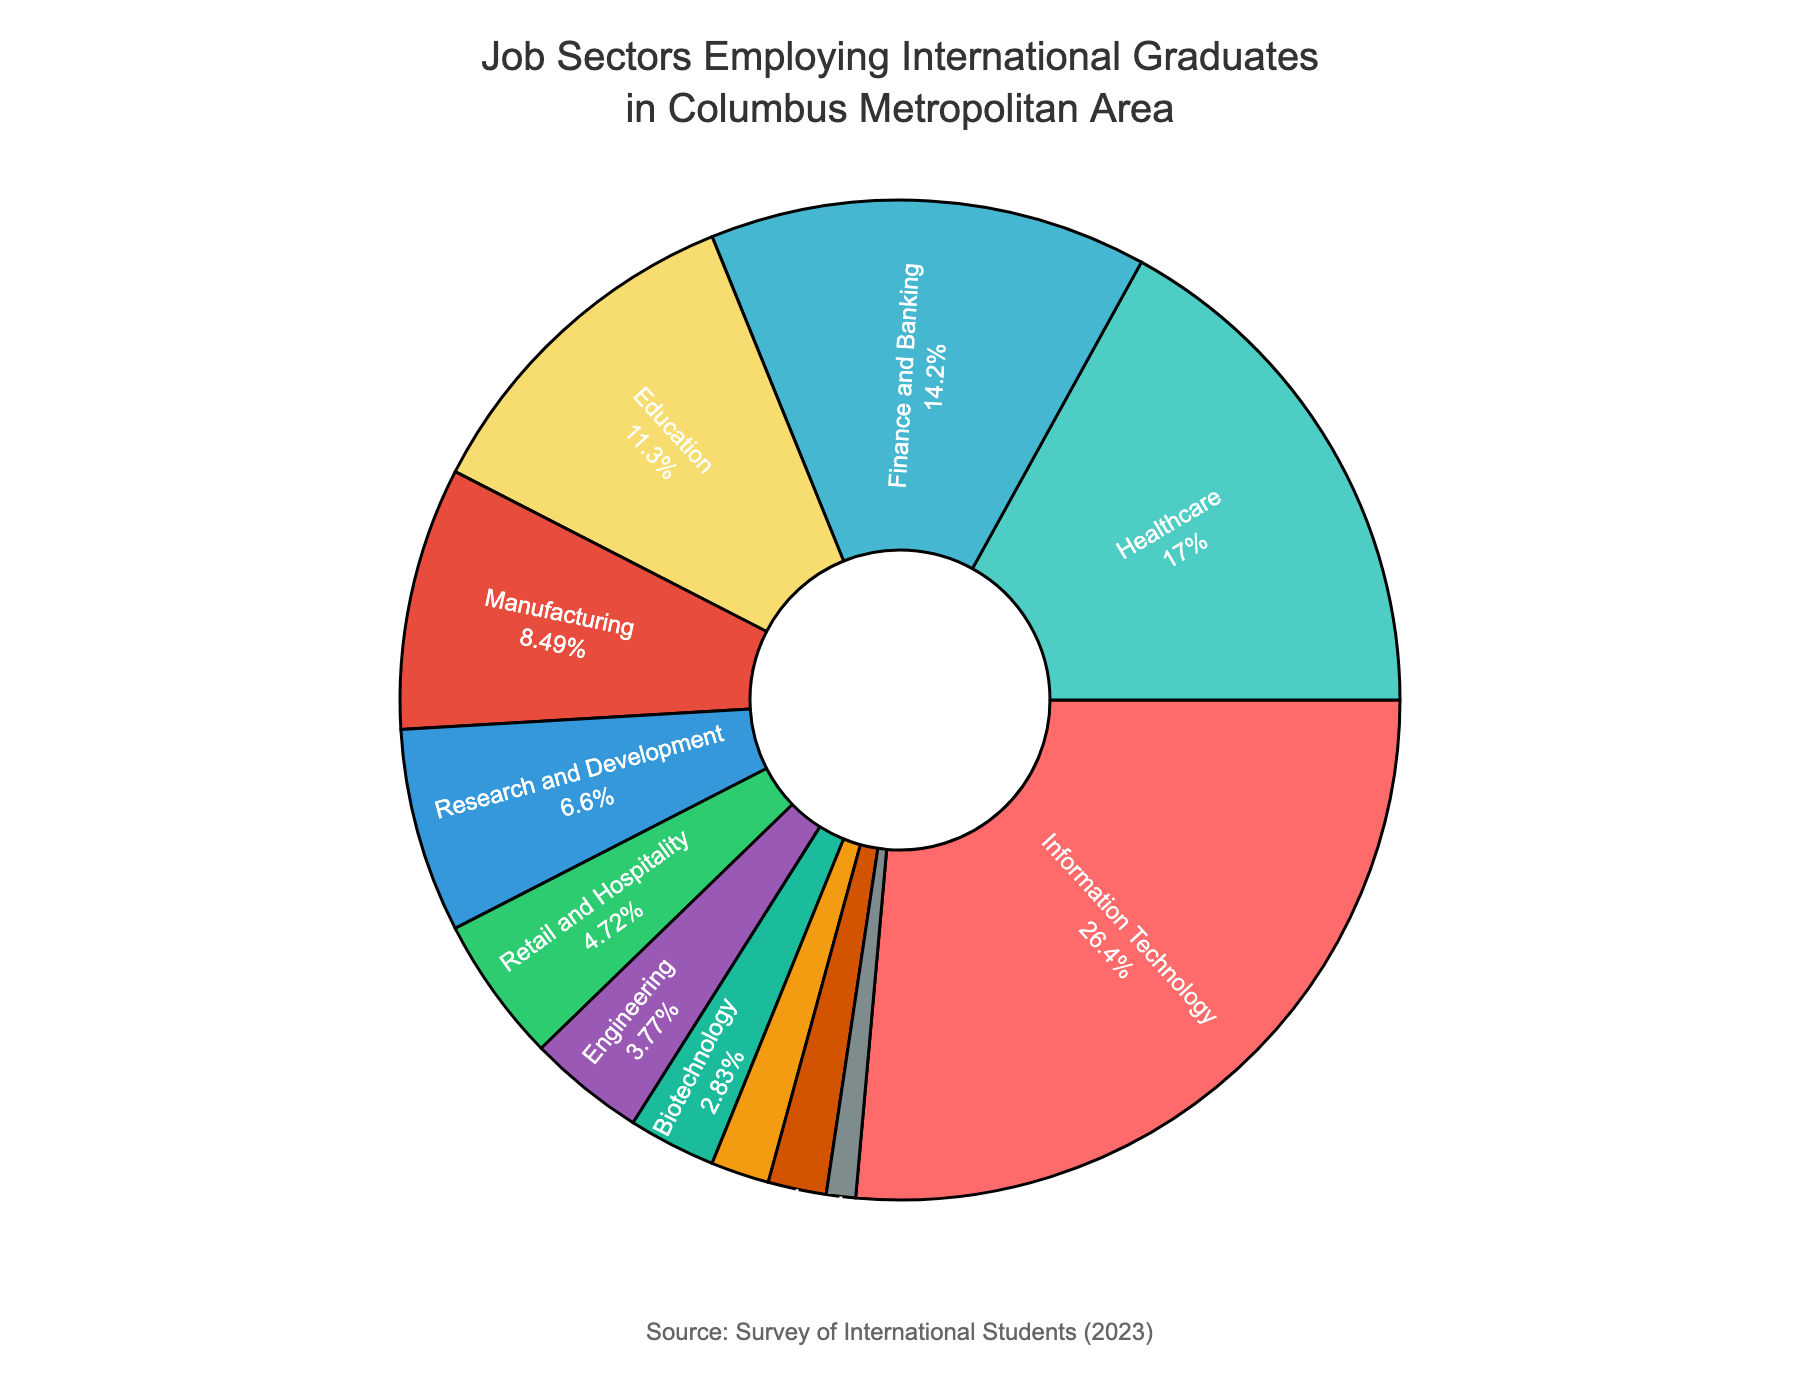What's the sector with the highest employment percentage for international graduates? The highest employment percentage can be determined from the pie chart by identifying the largest section. The largest section is labeled "Information Technology" with 28%.
Answer: Information Technology Which sector has a higher employment percentage, Healthcare or Manufacturing? To answer this, compare the percentages of the Healthcare and Manufacturing sectors. Healthcare has 18%, and Manufacturing has 9%. Since 18% is greater than 9%, Healthcare has a higher employment percentage.
Answer: Healthcare What is the combined employment percentage for Finance and Banking, and Education sectors? Add the percentages of the Finance and Banking sector (15%) and the Education sector (12%). 15% + 12% = 27%.
Answer: 27% How much larger is the employment percentage of Information Technology compared to Biotechnology? Find the difference between the percentages of Information Technology (28%) and Biotechnology (3%). 28% - 3% = 25%.
Answer: 25% Which sectors have an employment percentage less than 5%? Examine the pie chart for sections with less than 5%: Retail and Hospitality (5%), Engineering (4%), Biotechnology (3%), Logistics and Transportation (2%), Consulting (2%), and Non-profit Organizations (1%). Exclude Retail and Hospitality since it is exactly 5%. This leaves Engineering, Biotechnology, Logistics and Transportation, Consulting, and Non-profit Organizations.
Answer: Engineering, Biotechnology, Logistics and Transportation, Consulting, Non-profit Organizations Between Education and Research and Development, which has a lower employment percentage and by how much? Education has 12%, and Research and Development has 7%. The difference is 12% - 7% = 5%. Therefore, Research and Development is lower by 5%.
Answer: Research and Development, 5% What percentage of international graduates are employed in sectors other than Information Technology and Healthcare? Subtract the combined percentage of Information Technology (28%) and Healthcare (18%) from 100%. 100% - (28% + 18%) = 54%.
Answer: 54% How does the employment percentage of Non-profit Organizations compare to that of Logistics and Transportation? Compare the percentages of Non-profit Organizations (1%) and Logistics and Transportation (2%). Since 1% is less than 2%, Non-profit Organizations has a lower employment percentage.
Answer: Non-profit Organizations If you add the employment percentages of Healthcare, Manufacturing, and Research and Development sectors, what is the total? Add the percentages: Healthcare (18%), Manufacturing (9%), and Research and Development (7%). 18% + 9% + 7% = 34%.
Answer: 34% Which sector is represented by the purple color in the pie chart? By assessing the pie chart, the purple section represents Manufacturing.
Answer: Manufacturing 